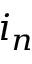<formula> <loc_0><loc_0><loc_500><loc_500>i _ { n }</formula> 